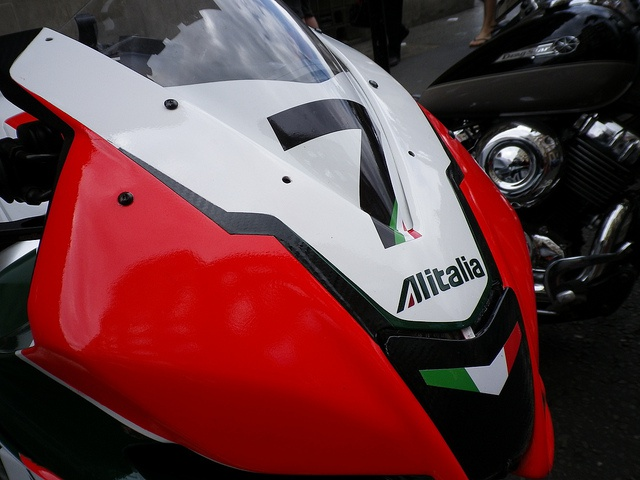Describe the objects in this image and their specific colors. I can see motorcycle in black, brown, lightgray, and maroon tones, motorcycle in black, gray, lightgray, and darkgray tones, people in black, gray, and maroon tones, and people in black, maroon, and brown tones in this image. 